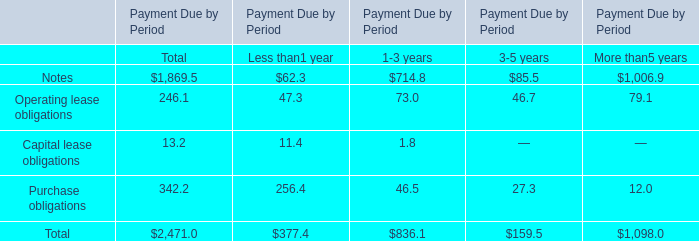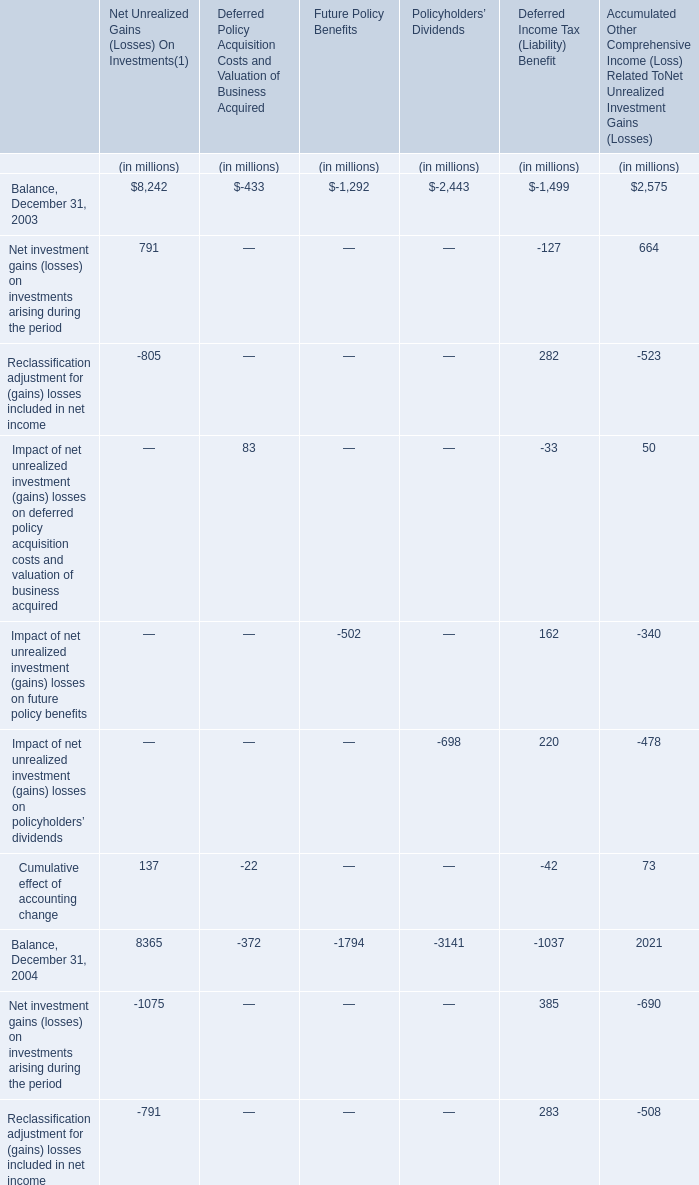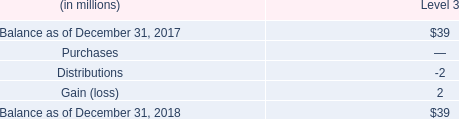What will Balance for Net Unrealized Gains On Investments on December 31 be like in 2006 if it develops with the same growth rate in 2005? (in million) 
Computations: (6499 * (1 + ((6499 - 8365) / 8365)))
Answer: 5049.25296. 